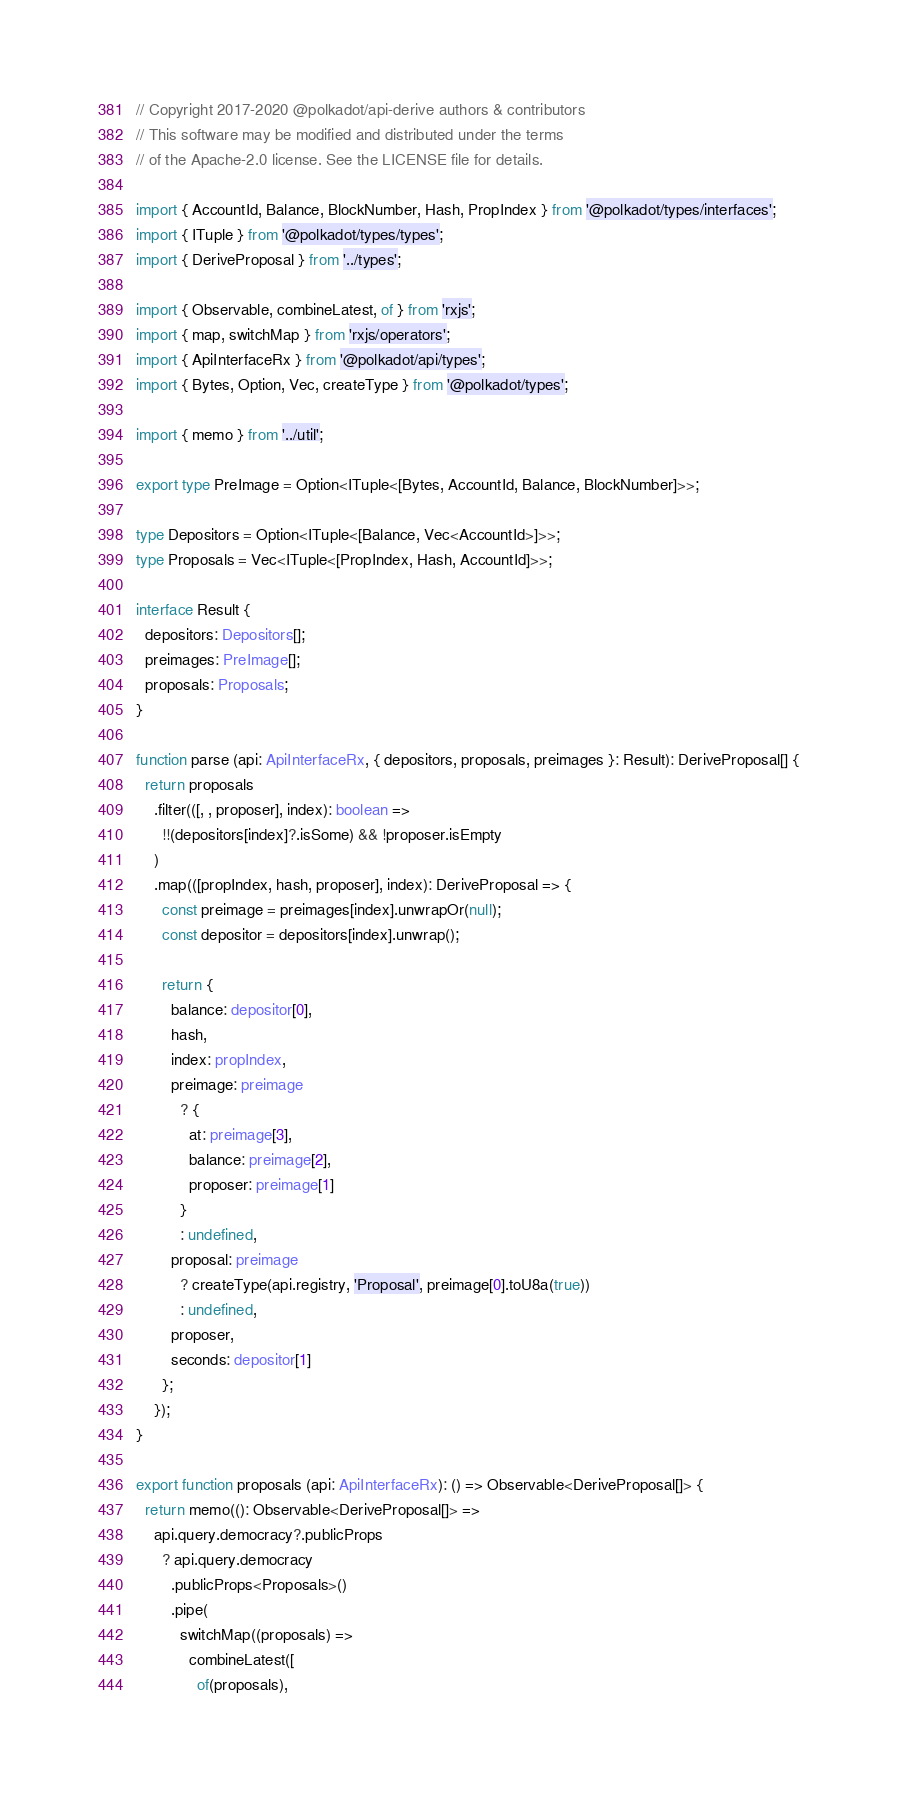Convert code to text. <code><loc_0><loc_0><loc_500><loc_500><_TypeScript_>// Copyright 2017-2020 @polkadot/api-derive authors & contributors
// This software may be modified and distributed under the terms
// of the Apache-2.0 license. See the LICENSE file for details.

import { AccountId, Balance, BlockNumber, Hash, PropIndex } from '@polkadot/types/interfaces';
import { ITuple } from '@polkadot/types/types';
import { DeriveProposal } from '../types';

import { Observable, combineLatest, of } from 'rxjs';
import { map, switchMap } from 'rxjs/operators';
import { ApiInterfaceRx } from '@polkadot/api/types';
import { Bytes, Option, Vec, createType } from '@polkadot/types';

import { memo } from '../util';

export type PreImage = Option<ITuple<[Bytes, AccountId, Balance, BlockNumber]>>;

type Depositors = Option<ITuple<[Balance, Vec<AccountId>]>>;
type Proposals = Vec<ITuple<[PropIndex, Hash, AccountId]>>;

interface Result {
  depositors: Depositors[];
  preimages: PreImage[];
  proposals: Proposals;
}

function parse (api: ApiInterfaceRx, { depositors, proposals, preimages }: Result): DeriveProposal[] {
  return proposals
    .filter(([, , proposer], index): boolean =>
      !!(depositors[index]?.isSome) && !proposer.isEmpty
    )
    .map(([propIndex, hash, proposer], index): DeriveProposal => {
      const preimage = preimages[index].unwrapOr(null);
      const depositor = depositors[index].unwrap();

      return {
        balance: depositor[0],
        hash,
        index: propIndex,
        preimage: preimage
          ? {
            at: preimage[3],
            balance: preimage[2],
            proposer: preimage[1]
          }
          : undefined,
        proposal: preimage
          ? createType(api.registry, 'Proposal', preimage[0].toU8a(true))
          : undefined,
        proposer,
        seconds: depositor[1]
      };
    });
}

export function proposals (api: ApiInterfaceRx): () => Observable<DeriveProposal[]> {
  return memo((): Observable<DeriveProposal[]> =>
    api.query.democracy?.publicProps
      ? api.query.democracy
        .publicProps<Proposals>()
        .pipe(
          switchMap((proposals) =>
            combineLatest([
              of(proposals),</code> 